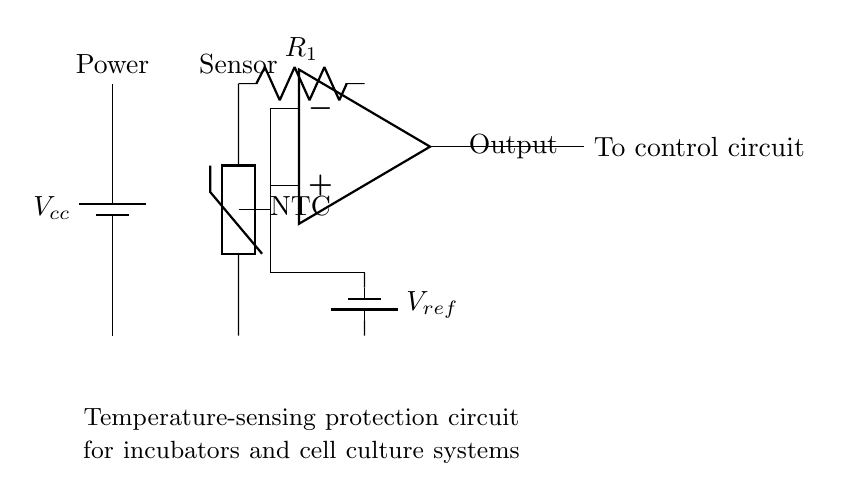What type of temperature sensor is used? The circuit uses an NTC thermistor, which is identified by the labeling on the component in the diagram. NTC indicates that the resistance decreases as the temperature increases, suitable for temperature measurement.
Answer: NTC thermistor What is the role of the resistor in this circuit? The resistor, labeled R1, serves as part of a voltage divider that helps to create a reference voltage for the comparator. The output from the voltage divider and the thermistor is compared to determine if the temperature exceeds a certain threshold.
Answer: Voltage divider What is the reference voltage source in the circuit? The circuit features a reference voltage supplied by a battery, indicated by the labeling Vref. This voltage is crucial for setting the threshold against which the thermistor's output is compared.
Answer: Battery How many op-amps are present in this circuit? There is one operational amplifier in the circuit, which is indicated by the op-amp symbol in the diagram. This component is used to compare the input from the thermistor and the reference voltage to control the output regarding the temperature.
Answer: One At which point does the output of the comparator go? The output of the comparator is directed towards a control circuit. This connection is explicitly shown in the diagram, indicating that the comparator will send signals to manage or shut down the system based on temperature.
Answer: Control circuit What happens if the temperature exceeds the reference voltage? If the temperature exceeds the reference voltage, the comparator will trigger the control output, which can lead to the activation of alarms or safety measures within the incubator or cell culture system to prevent overheating.
Answer: Activates control 